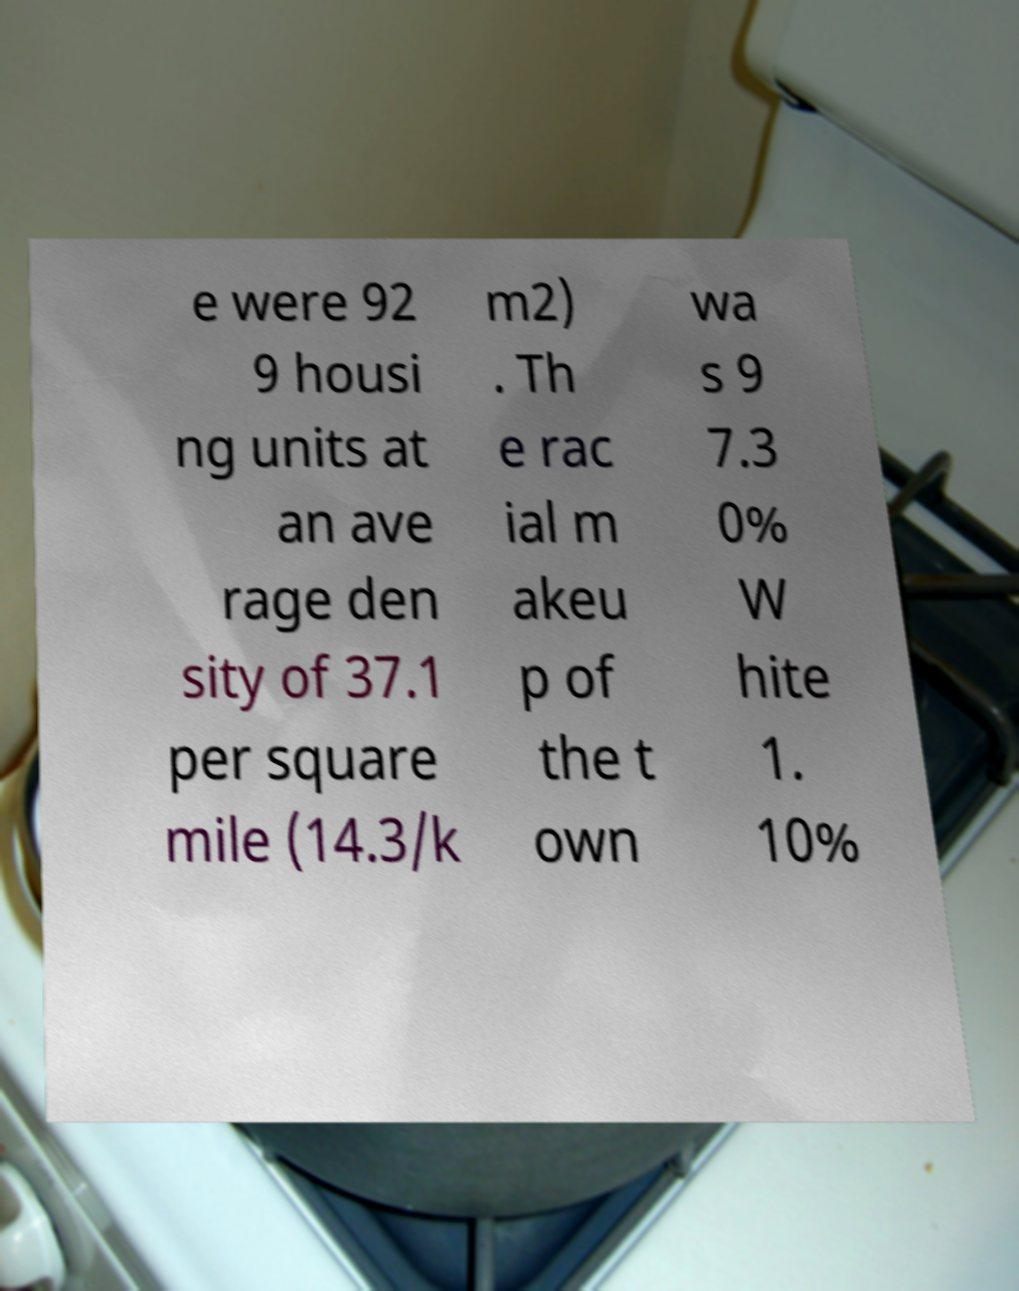Please read and relay the text visible in this image. What does it say? e were 92 9 housi ng units at an ave rage den sity of 37.1 per square mile (14.3/k m2) . Th e rac ial m akeu p of the t own wa s 9 7.3 0% W hite 1. 10% 